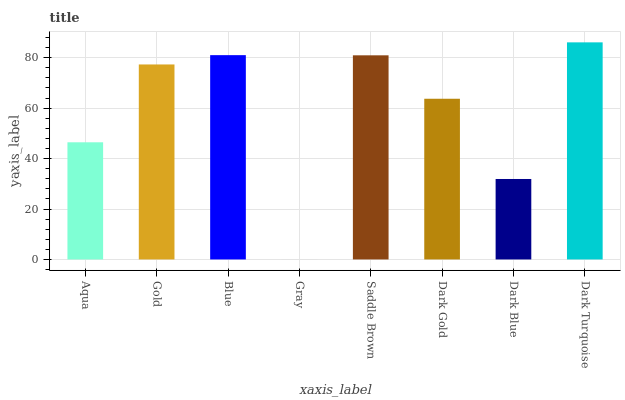Is Gray the minimum?
Answer yes or no. Yes. Is Dark Turquoise the maximum?
Answer yes or no. Yes. Is Gold the minimum?
Answer yes or no. No. Is Gold the maximum?
Answer yes or no. No. Is Gold greater than Aqua?
Answer yes or no. Yes. Is Aqua less than Gold?
Answer yes or no. Yes. Is Aqua greater than Gold?
Answer yes or no. No. Is Gold less than Aqua?
Answer yes or no. No. Is Gold the high median?
Answer yes or no. Yes. Is Dark Gold the low median?
Answer yes or no. Yes. Is Gray the high median?
Answer yes or no. No. Is Dark Turquoise the low median?
Answer yes or no. No. 